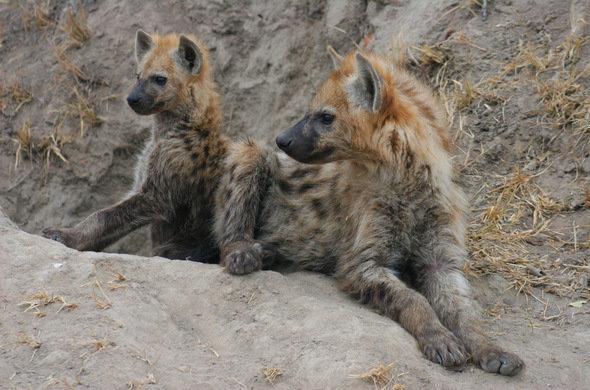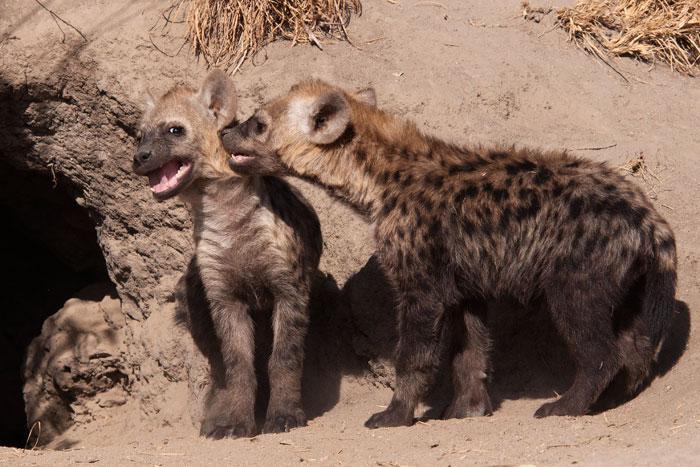The first image is the image on the left, the second image is the image on the right. Given the left and right images, does the statement "the right side image has only two animals" hold true? Answer yes or no. Yes. The first image is the image on the left, the second image is the image on the right. Evaluate the accuracy of this statement regarding the images: "there are a minimum of 7 hyenas present.". Is it true? Answer yes or no. No. 